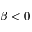Convert formula to latex. <formula><loc_0><loc_0><loc_500><loc_500>\beta < 0</formula> 